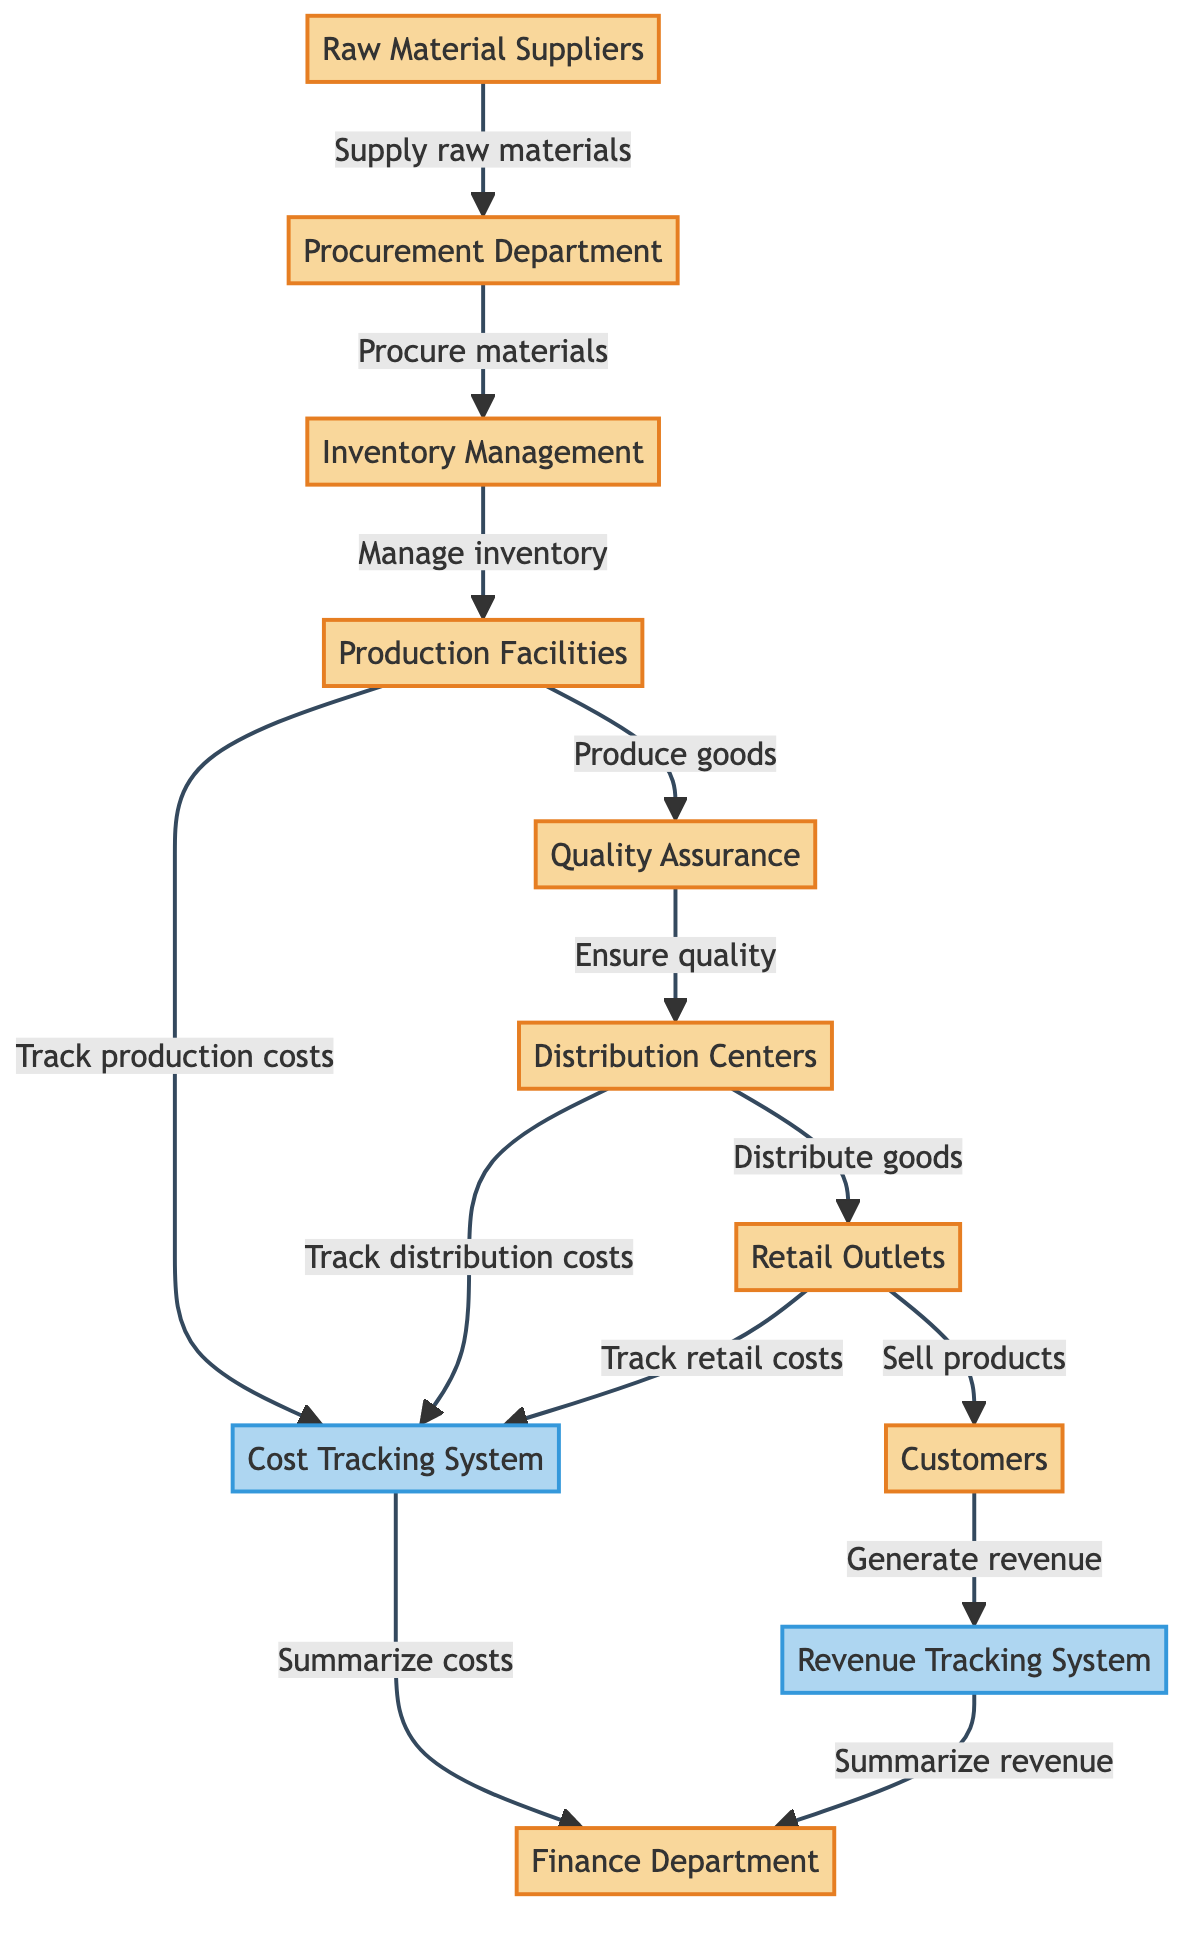What's the first node in the food chain? The diagram starts with "Raw Material Suppliers" as the first node, indicating where the supply chain begins.
Answer: Raw Material Suppliers How many entities are in the diagram? The entities are all the nodes involved in the flow of the food chain. There are eight entities in total: Raw Material Suppliers, Procurement Department, Inventory Management, Production Facilities, Quality Assurance, Distribution Centers, Retail Outlets, and Customers.
Answer: 8 Which department is responsible for summarizing revenue? According to the diagram, the "Finance Department" is responsible for summarizing revenue, as indicated by its connection to the Revenue Tracking System.
Answer: Finance Department How do goods reach customers? The flow indicates that goods move from Retail Outlets to Customers, meaning Retail Outlets sell the products to the Customers.
Answer: Retail Outlets What type of costs does the Finance Department summarize? The Finance Department summarizes the costs tracked from various systems, specifically the production costs, distribution costs, and retail costs, which are all related to the overall expenses in the food chain.
Answer: Costs 